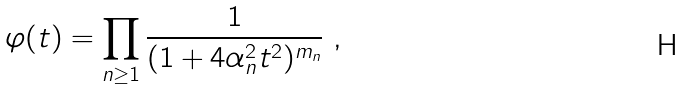Convert formula to latex. <formula><loc_0><loc_0><loc_500><loc_500>\varphi ( t ) = \prod _ { n \geq 1 } \frac { 1 } { ( 1 + 4 \alpha ^ { 2 } _ { n } t ^ { 2 } ) ^ { m _ { n } } } \ ,</formula> 